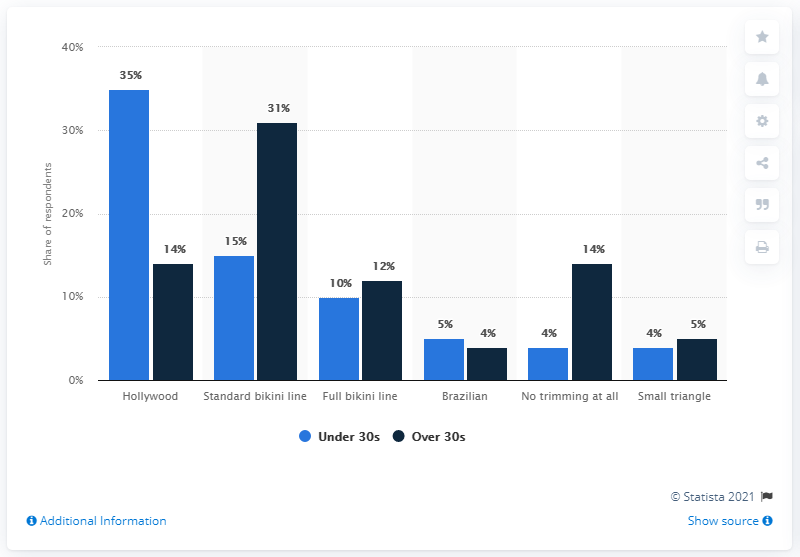Indicate a few pertinent items in this graphic. The least common type of pubic hair style is either Brazilian or small triangle. The total number of bikini lines (standard or full) for women aged over 30 is 43. 